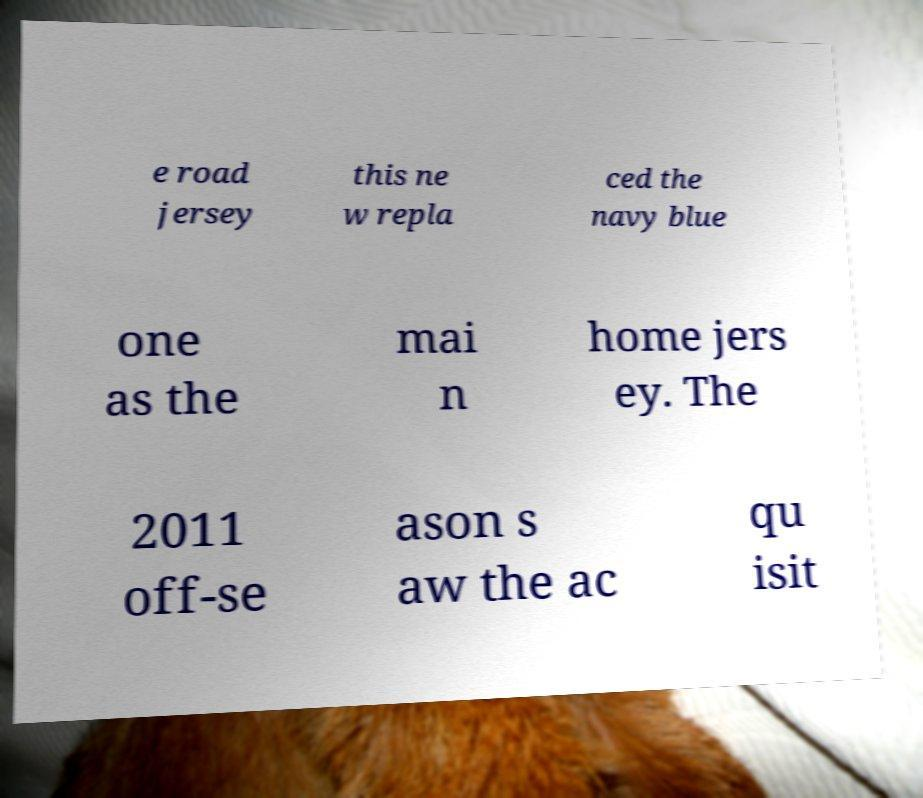Could you extract and type out the text from this image? e road jersey this ne w repla ced the navy blue one as the mai n home jers ey. The 2011 off-se ason s aw the ac qu isit 